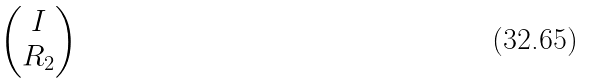Convert formula to latex. <formula><loc_0><loc_0><loc_500><loc_500>\begin{pmatrix} I \\ R _ { 2 } \end{pmatrix}</formula> 